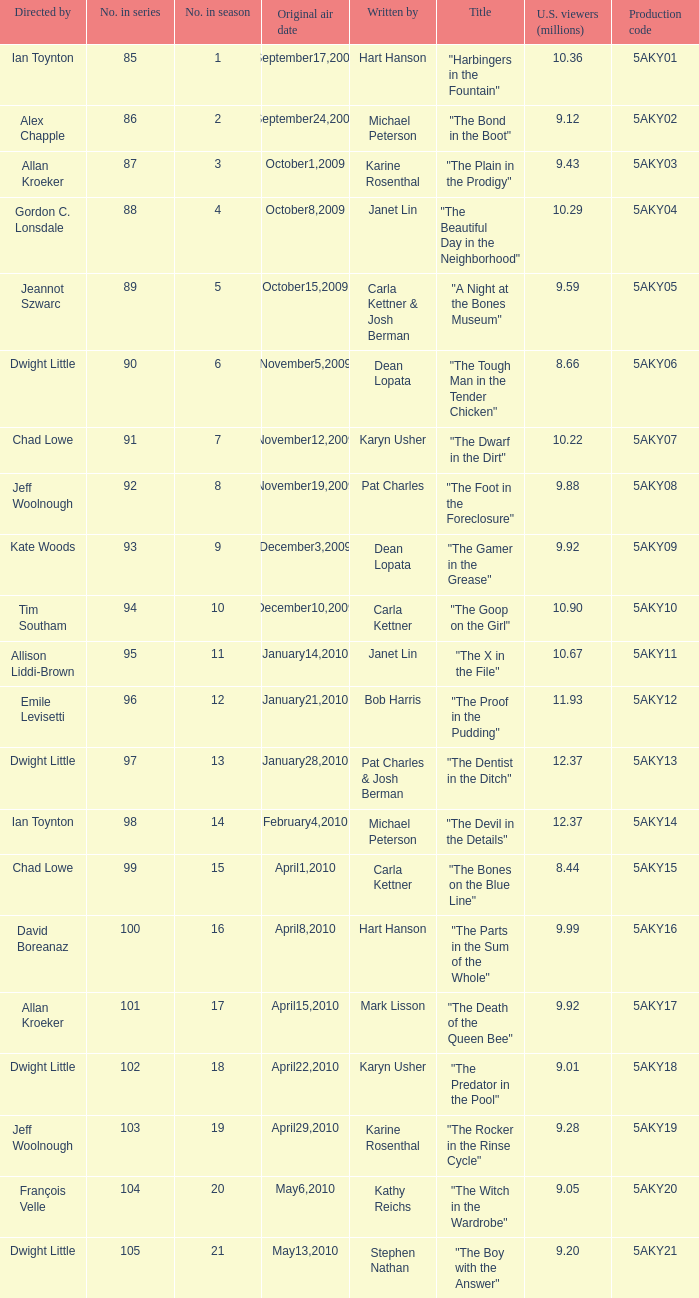What was the air date of the episode that has a production code of 5aky13? January28,2010. Would you be able to parse every entry in this table? {'header': ['Directed by', 'No. in series', 'No. in season', 'Original air date', 'Written by', 'Title', 'U.S. viewers (millions)', 'Production code'], 'rows': [['Ian Toynton', '85', '1', 'September17,2009', 'Hart Hanson', '"Harbingers in the Fountain"', '10.36', '5AKY01'], ['Alex Chapple', '86', '2', 'September24,2009', 'Michael Peterson', '"The Bond in the Boot"', '9.12', '5AKY02'], ['Allan Kroeker', '87', '3', 'October1,2009', 'Karine Rosenthal', '"The Plain in the Prodigy"', '9.43', '5AKY03'], ['Gordon C. Lonsdale', '88', '4', 'October8,2009', 'Janet Lin', '"The Beautiful Day in the Neighborhood"', '10.29', '5AKY04'], ['Jeannot Szwarc', '89', '5', 'October15,2009', 'Carla Kettner & Josh Berman', '"A Night at the Bones Museum"', '9.59', '5AKY05'], ['Dwight Little', '90', '6', 'November5,2009', 'Dean Lopata', '"The Tough Man in the Tender Chicken"', '8.66', '5AKY06'], ['Chad Lowe', '91', '7', 'November12,2009', 'Karyn Usher', '"The Dwarf in the Dirt"', '10.22', '5AKY07'], ['Jeff Woolnough', '92', '8', 'November19,2009', 'Pat Charles', '"The Foot in the Foreclosure"', '9.88', '5AKY08'], ['Kate Woods', '93', '9', 'December3,2009', 'Dean Lopata', '"The Gamer in the Grease"', '9.92', '5AKY09'], ['Tim Southam', '94', '10', 'December10,2009', 'Carla Kettner', '"The Goop on the Girl"', '10.90', '5AKY10'], ['Allison Liddi-Brown', '95', '11', 'January14,2010', 'Janet Lin', '"The X in the File"', '10.67', '5AKY11'], ['Emile Levisetti', '96', '12', 'January21,2010', 'Bob Harris', '"The Proof in the Pudding"', '11.93', '5AKY12'], ['Dwight Little', '97', '13', 'January28,2010', 'Pat Charles & Josh Berman', '"The Dentist in the Ditch"', '12.37', '5AKY13'], ['Ian Toynton', '98', '14', 'February4,2010', 'Michael Peterson', '"The Devil in the Details"', '12.37', '5AKY14'], ['Chad Lowe', '99', '15', 'April1,2010', 'Carla Kettner', '"The Bones on the Blue Line"', '8.44', '5AKY15'], ['David Boreanaz', '100', '16', 'April8,2010', 'Hart Hanson', '"The Parts in the Sum of the Whole"', '9.99', '5AKY16'], ['Allan Kroeker', '101', '17', 'April15,2010', 'Mark Lisson', '"The Death of the Queen Bee"', '9.92', '5AKY17'], ['Dwight Little', '102', '18', 'April22,2010', 'Karyn Usher', '"The Predator in the Pool"', '9.01', '5AKY18'], ['Jeff Woolnough', '103', '19', 'April29,2010', 'Karine Rosenthal', '"The Rocker in the Rinse Cycle"', '9.28', '5AKY19'], ['François Velle', '104', '20', 'May6,2010', 'Kathy Reichs', '"The Witch in the Wardrobe"', '9.05', '5AKY20'], ['Dwight Little', '105', '21', 'May13,2010', 'Stephen Nathan', '"The Boy with the Answer"', '9.20', '5AKY21']]} 